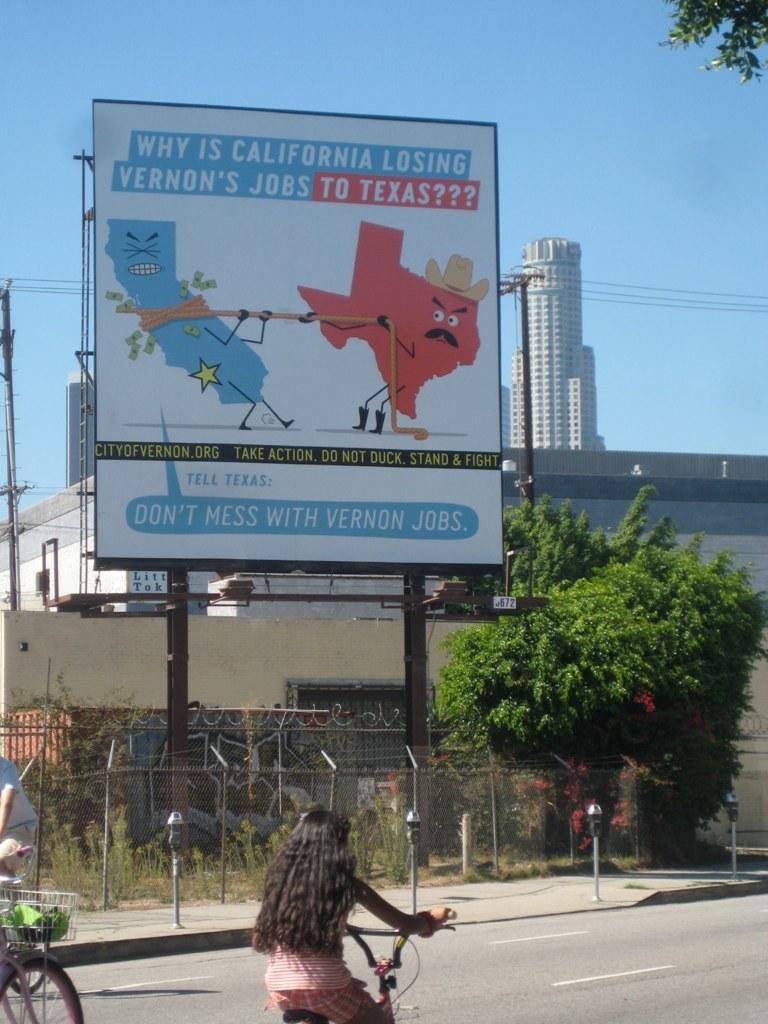Provide a one-sentence caption for the provided image. Two people riding their bikes past a billboard, about why California is loosing Vernon's jobs to Texas. 